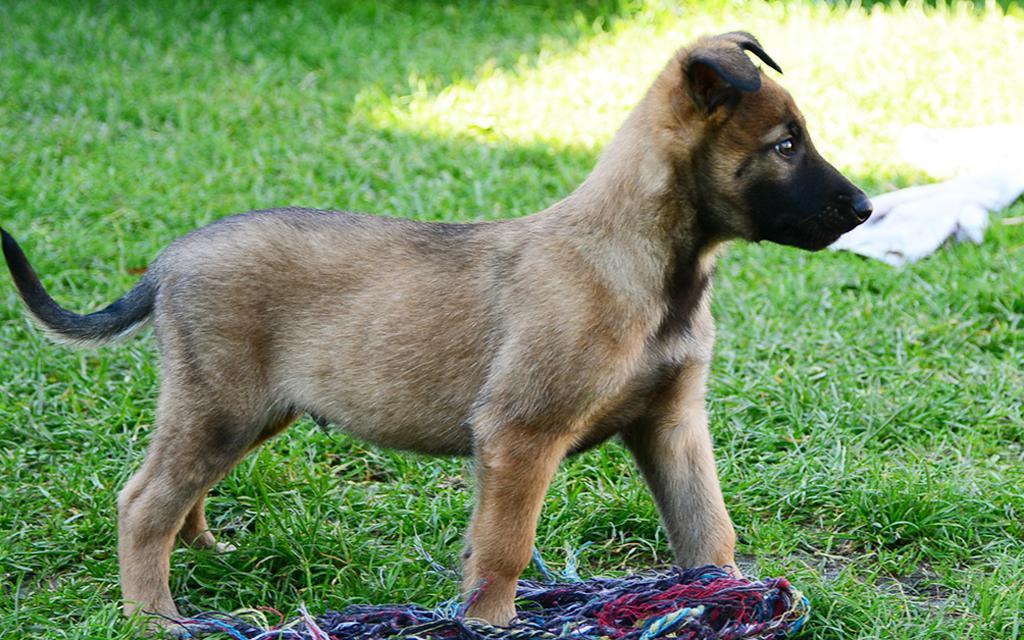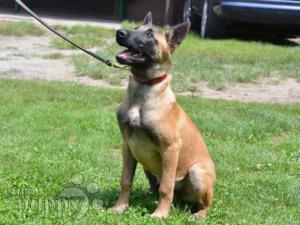The first image is the image on the left, the second image is the image on the right. Considering the images on both sides, is "In one of the images there is a dog attached to a leash." valid? Answer yes or no. Yes. The first image is the image on the left, the second image is the image on the right. Assess this claim about the two images: "An image shows exactly one german shepherd, which is sitting on the grass.". Correct or not? Answer yes or no. Yes. 